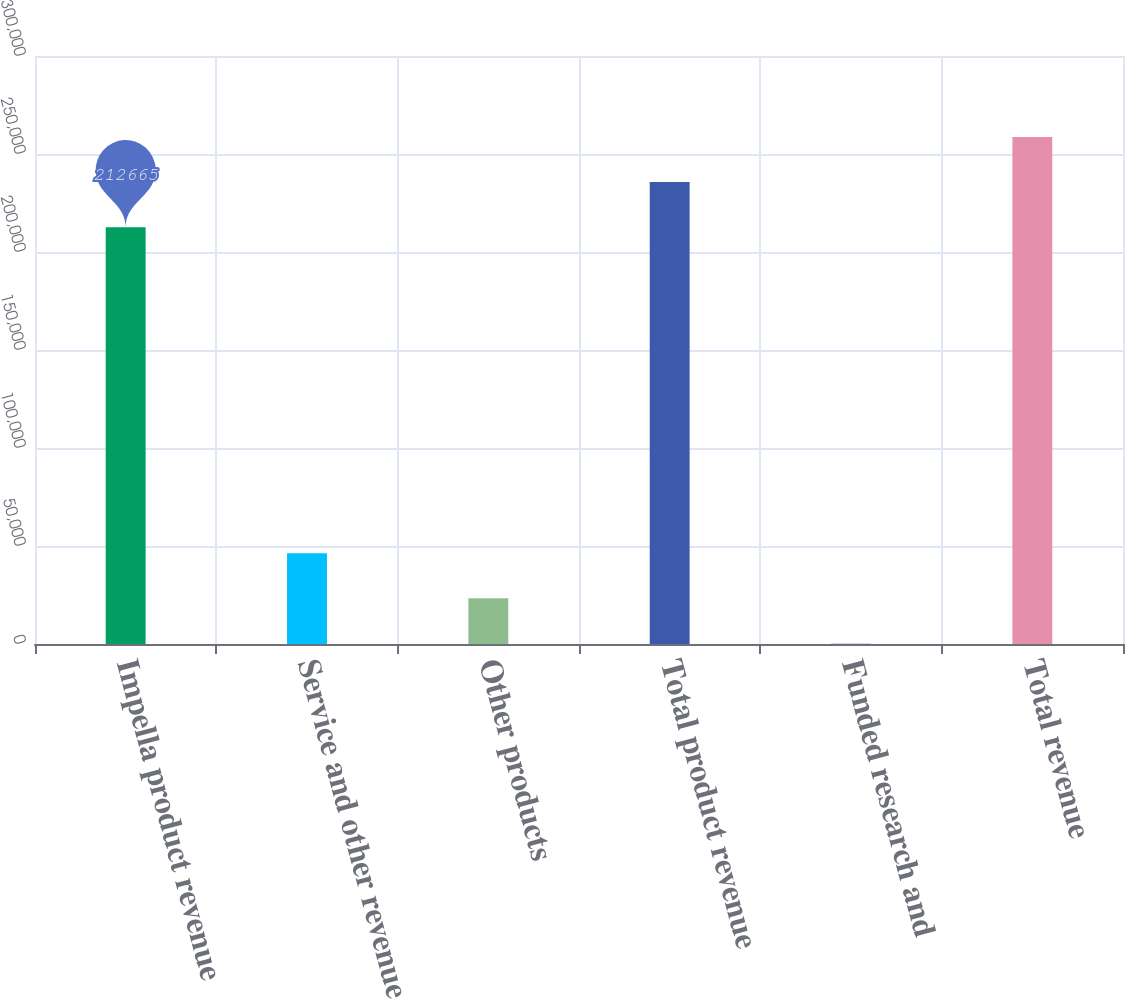Convert chart. <chart><loc_0><loc_0><loc_500><loc_500><bar_chart><fcel>Impella product revenue<fcel>Service and other revenue<fcel>Other products<fcel>Total product revenue<fcel>Funded research and<fcel>Total revenue<nl><fcel>212665<fcel>46351<fcel>23356<fcel>235660<fcel>361<fcel>258655<nl></chart> 